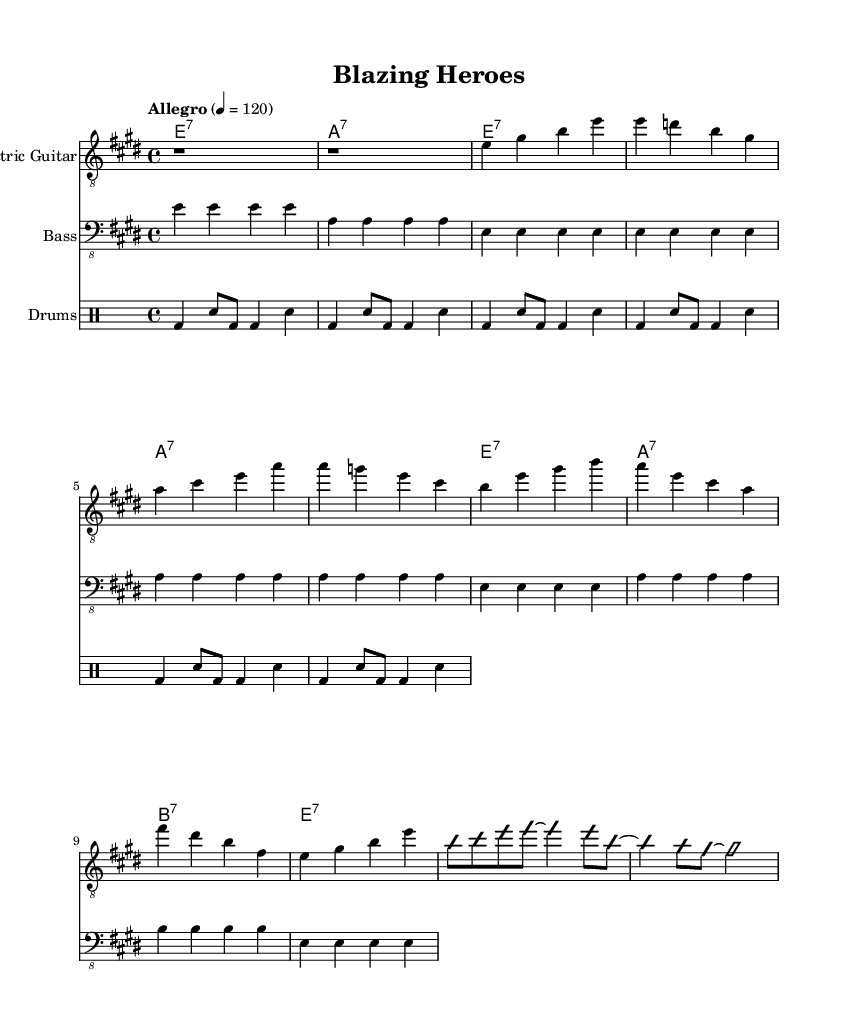What is the key signature of this music? The key signature of the piece is E major, which has four sharps (F#, C#, G#, and D#). This can be identified from the beginning of the score where the key signature is written.
Answer: E major What is the time signature of this music? The time signature is 4/4, indicated at the beginning of the score. In 4/4 time, there are four beats per measure, and the quarter note receives one beat.
Answer: 4/4 What is the tempo marking of this music? The tempo marking indicates "Allegro," with a specific beats per minute marking of 120. This can be found in the notation provided, which instructs the speed at which the piece should be performed.
Answer: Allegro 4 = 120 How many measures are in the verse? The verse consists of a total of 8 measures, as can be counted from the notated section under "Verse 1" which spans 8 bars. Each group of notes that fits within the line of the staff represents a measure.
Answer: 8 Which instrument has an improvisation section? The electric guitar has an improvisation section, as indicated by the markings "improvisationOn" and "improvisationOff" in the score. This instructs the performer to freely improvise during those measures.
Answer: Electric Guitar What type of chords are primarily used in this piece? The piece primarily utilizes dominant seventh chords, which are indicated with the notation (e1:7, a1:7, etc.). These chords are characteristic of the electric blues genre, providing a rich harmonic palette.
Answer: Dominant seventh chords What is celebrated in this blues piece? The piece celebrates the heroism and bravery of first responders, evident in the title "Blazing Heroes" and through the overall upbeat and uplifting nature of the music.
Answer: Heroism and bravery of first responders 